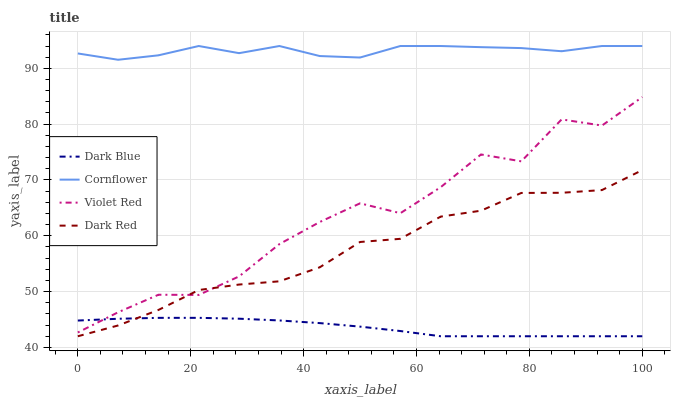Does Dark Blue have the minimum area under the curve?
Answer yes or no. Yes. Does Cornflower have the maximum area under the curve?
Answer yes or no. Yes. Does Violet Red have the minimum area under the curve?
Answer yes or no. No. Does Violet Red have the maximum area under the curve?
Answer yes or no. No. Is Dark Blue the smoothest?
Answer yes or no. Yes. Is Violet Red the roughest?
Answer yes or no. Yes. Is Dark Red the smoothest?
Answer yes or no. No. Is Dark Red the roughest?
Answer yes or no. No. Does Dark Blue have the lowest value?
Answer yes or no. Yes. Does Violet Red have the lowest value?
Answer yes or no. No. Does Cornflower have the highest value?
Answer yes or no. Yes. Does Violet Red have the highest value?
Answer yes or no. No. Is Violet Red less than Cornflower?
Answer yes or no. Yes. Is Cornflower greater than Violet Red?
Answer yes or no. Yes. Does Dark Red intersect Dark Blue?
Answer yes or no. Yes. Is Dark Red less than Dark Blue?
Answer yes or no. No. Is Dark Red greater than Dark Blue?
Answer yes or no. No. Does Violet Red intersect Cornflower?
Answer yes or no. No. 